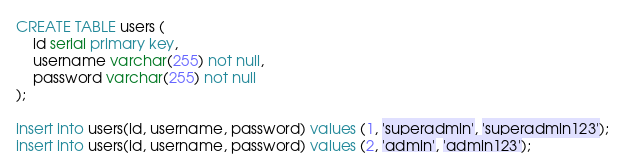<code> <loc_0><loc_0><loc_500><loc_500><_SQL_>
CREATE TABLE users (
	id serial primary key,
	username varchar(255) not null,
	password varchar(255) not null
);

insert into users(id, username, password) values (1, 'superadmin', 'superadmin123');
insert into users(id, username, password) values (2, 'admin', 'admin123');
</code> 